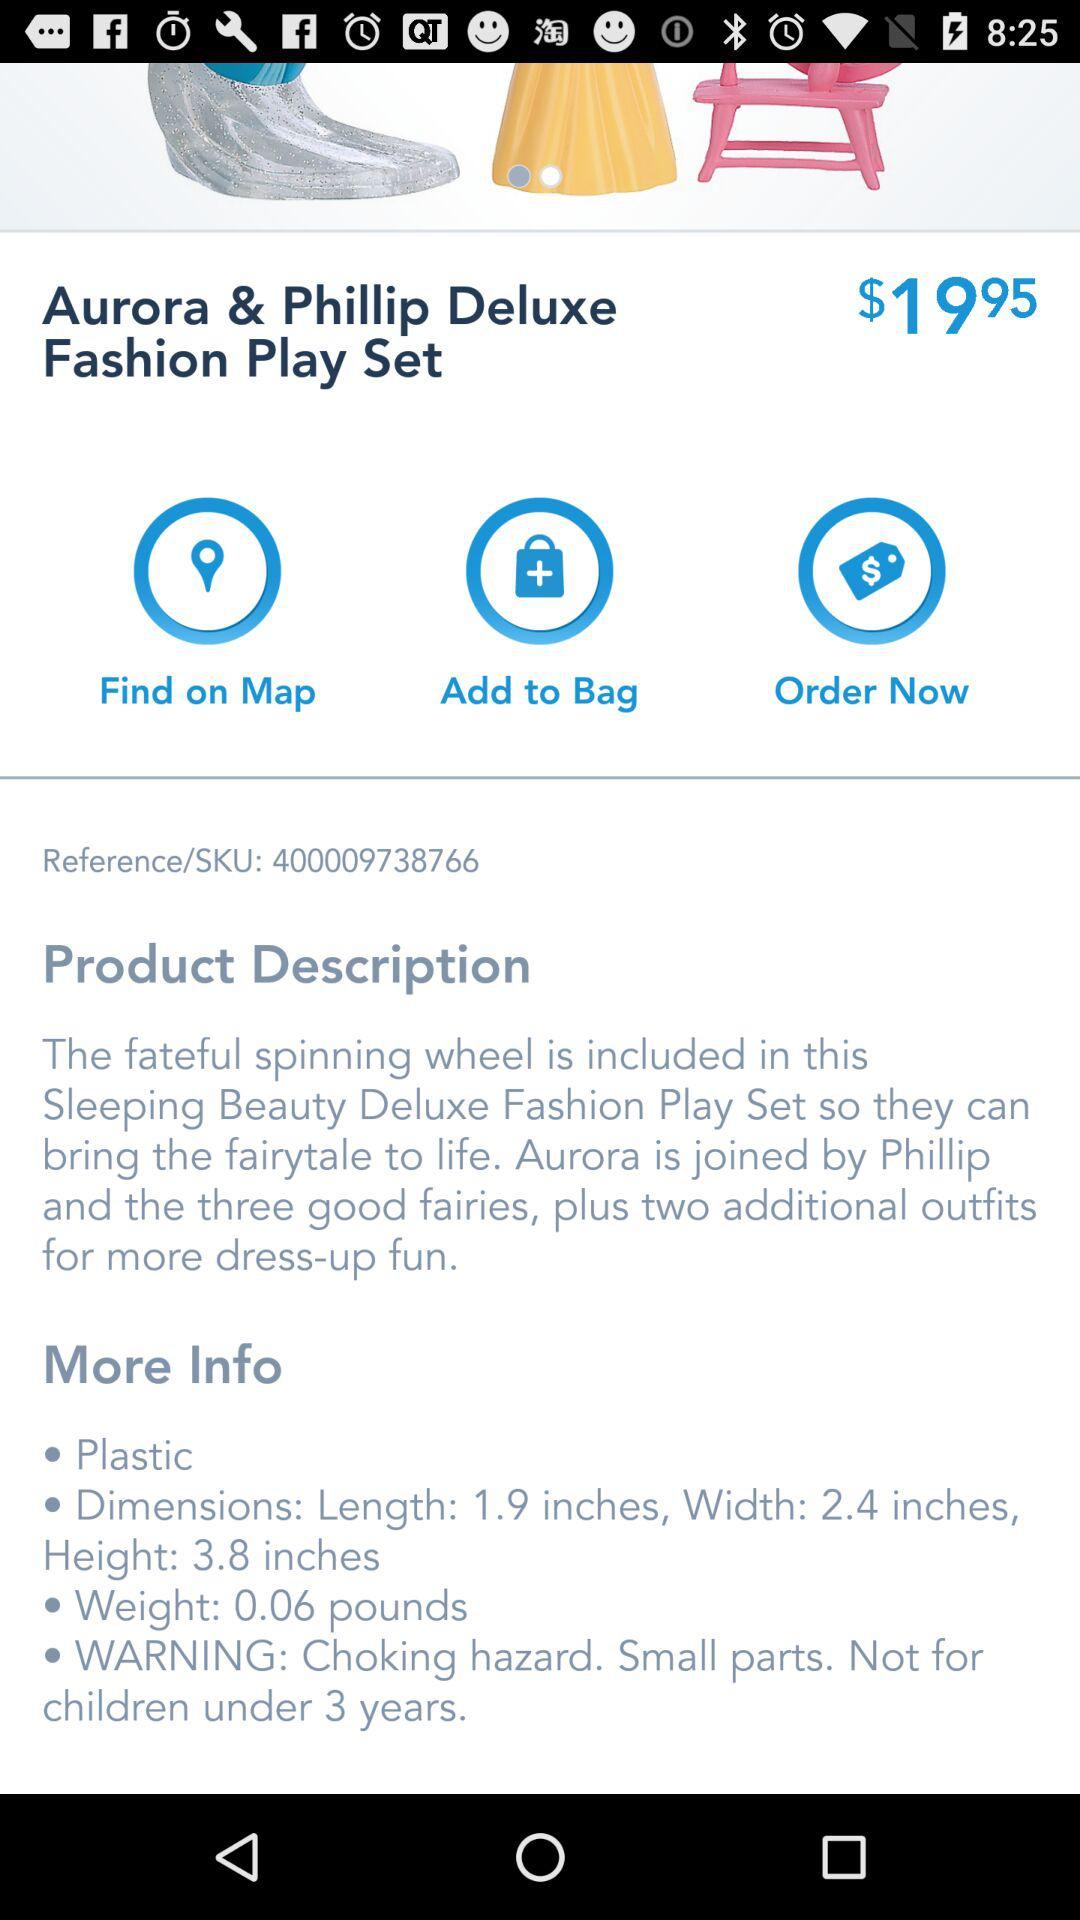What is the age limit for the play set?
When the provided information is insufficient, respond with <no answer>. <no answer> 